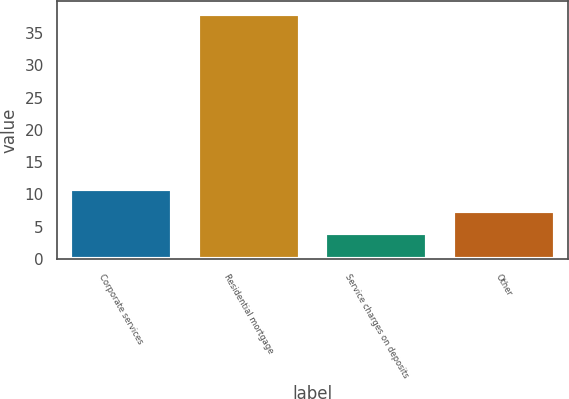<chart> <loc_0><loc_0><loc_500><loc_500><bar_chart><fcel>Corporate services<fcel>Residential mortgage<fcel>Service charges on deposits<fcel>Other<nl><fcel>10.8<fcel>38<fcel>4<fcel>7.4<nl></chart> 